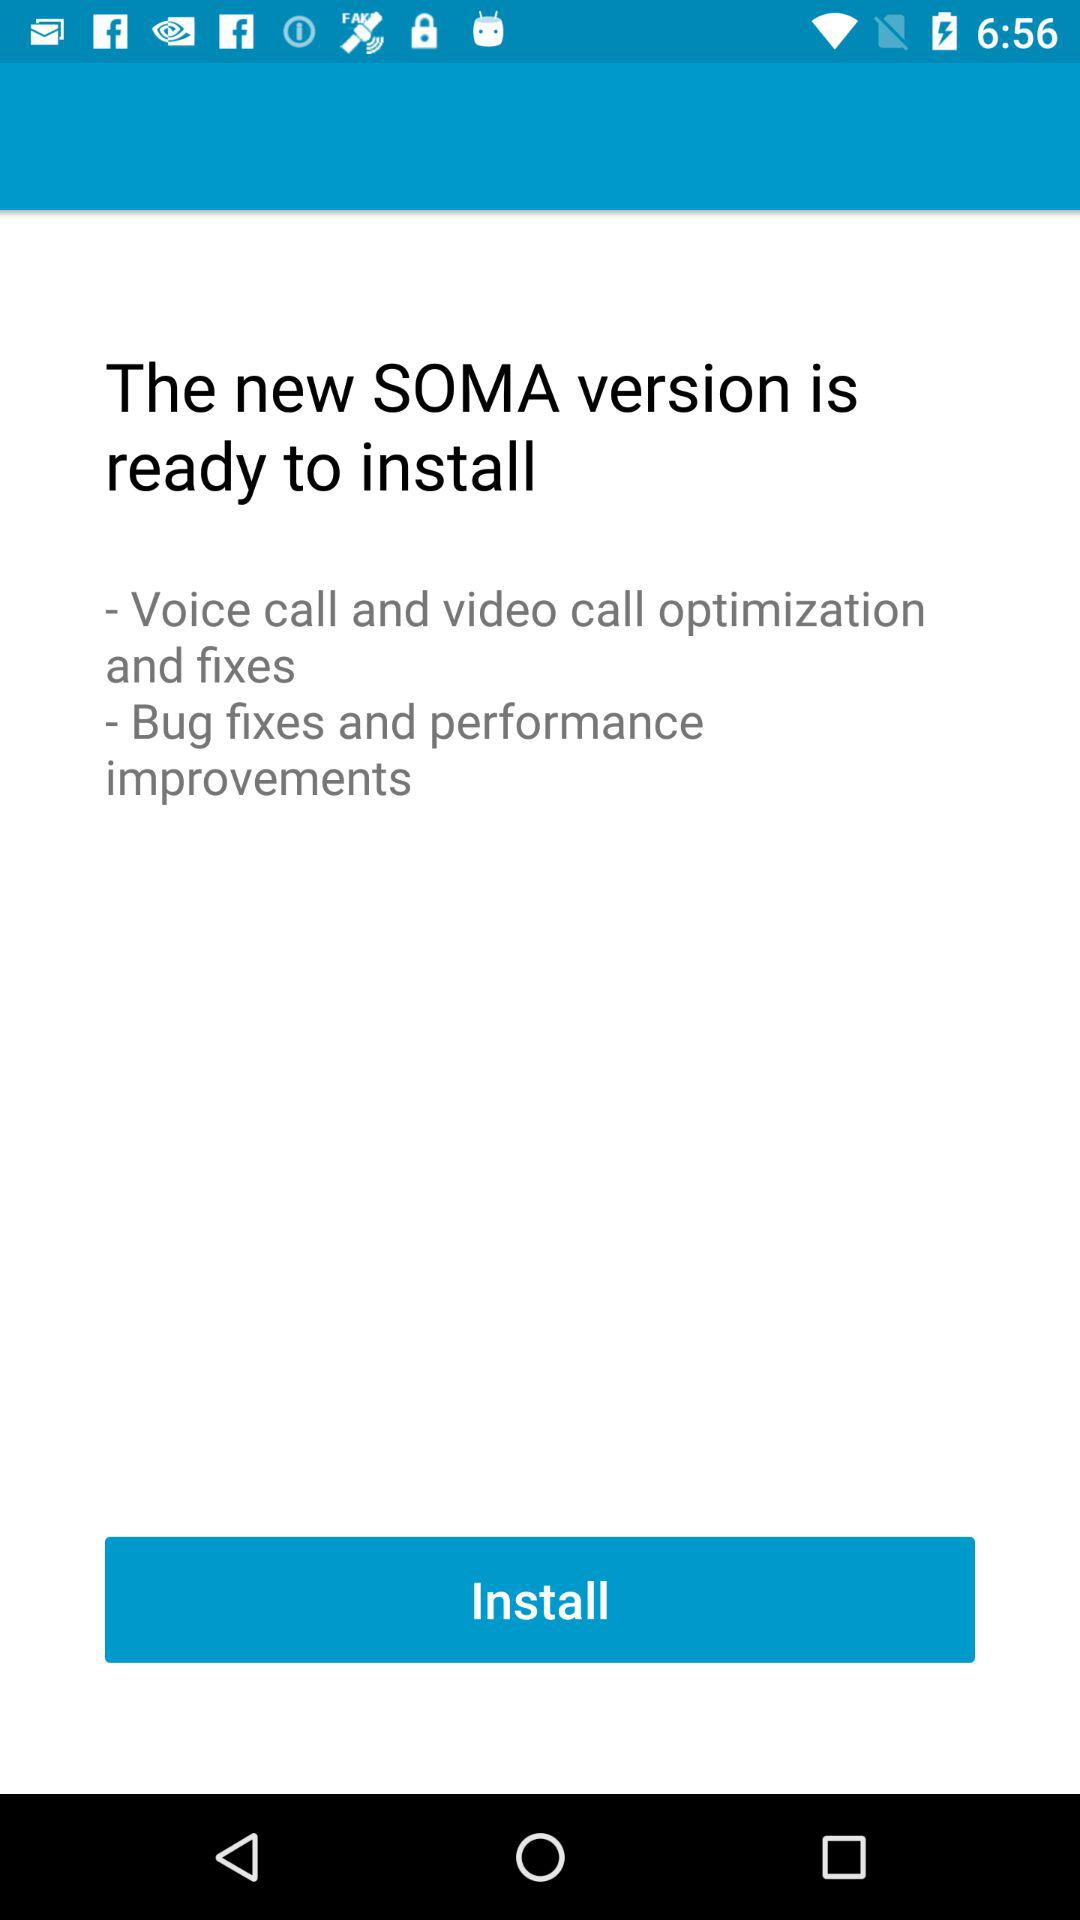What is the app name? The app name is "SOMA". 